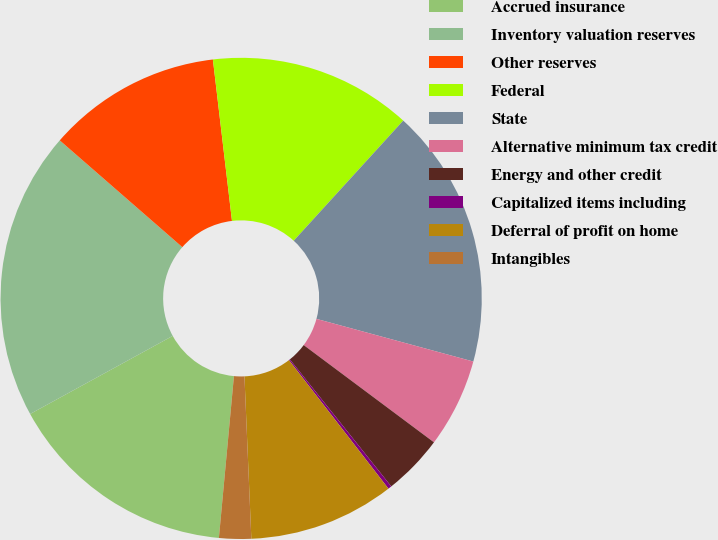Convert chart to OTSL. <chart><loc_0><loc_0><loc_500><loc_500><pie_chart><fcel>Accrued insurance<fcel>Inventory valuation reserves<fcel>Other reserves<fcel>Federal<fcel>State<fcel>Alternative minimum tax credit<fcel>Energy and other credit<fcel>Capitalized items including<fcel>Deferral of profit on home<fcel>Intangibles<nl><fcel>15.55%<fcel>19.38%<fcel>11.72%<fcel>13.64%<fcel>17.46%<fcel>5.98%<fcel>4.07%<fcel>0.24%<fcel>9.81%<fcel>2.15%<nl></chart> 